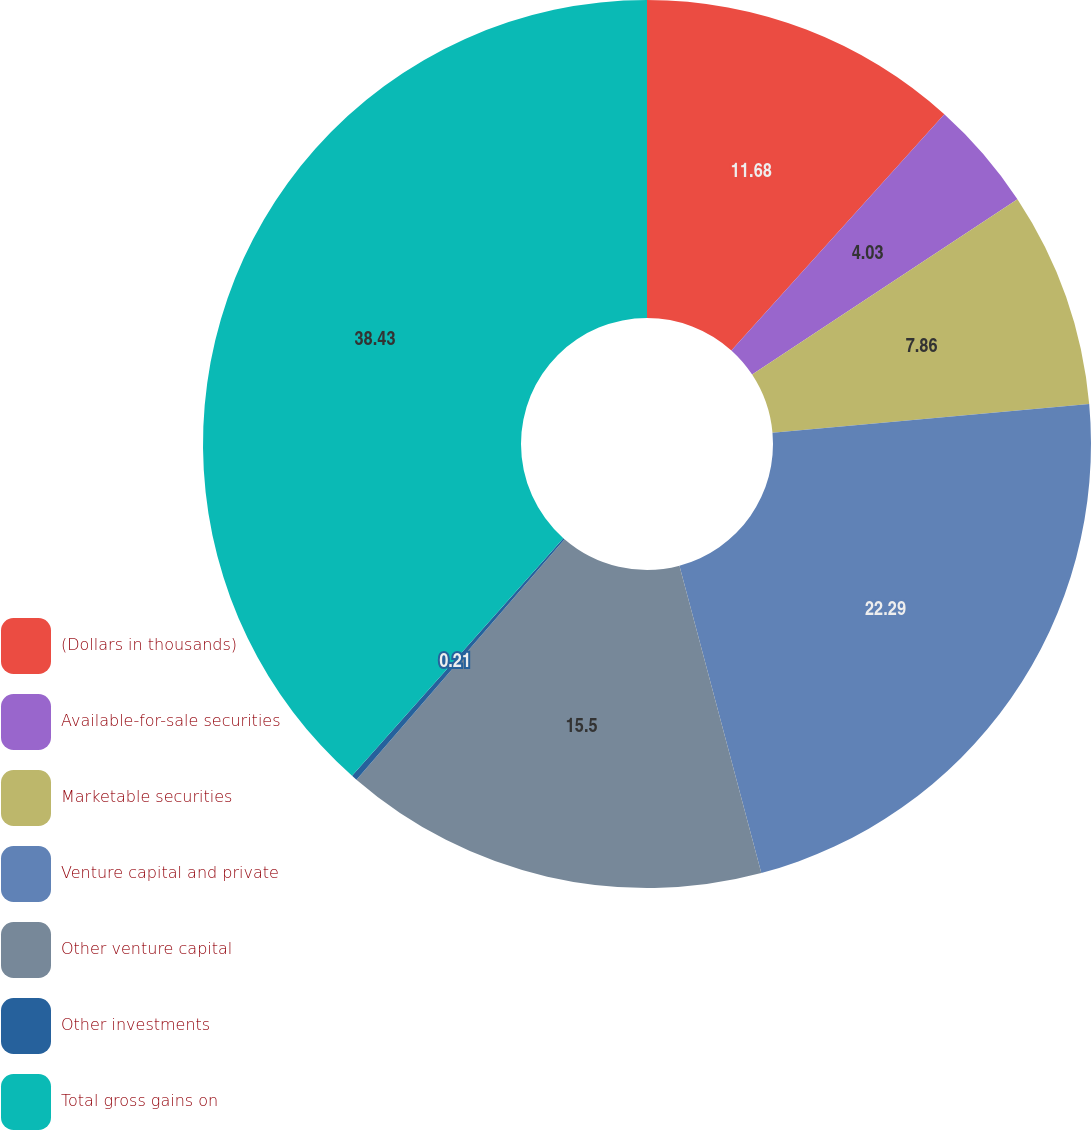Convert chart. <chart><loc_0><loc_0><loc_500><loc_500><pie_chart><fcel>(Dollars in thousands)<fcel>Available-for-sale securities<fcel>Marketable securities<fcel>Venture capital and private<fcel>Other venture capital<fcel>Other investments<fcel>Total gross gains on<nl><fcel>11.68%<fcel>4.03%<fcel>7.86%<fcel>22.29%<fcel>15.5%<fcel>0.21%<fcel>38.44%<nl></chart> 